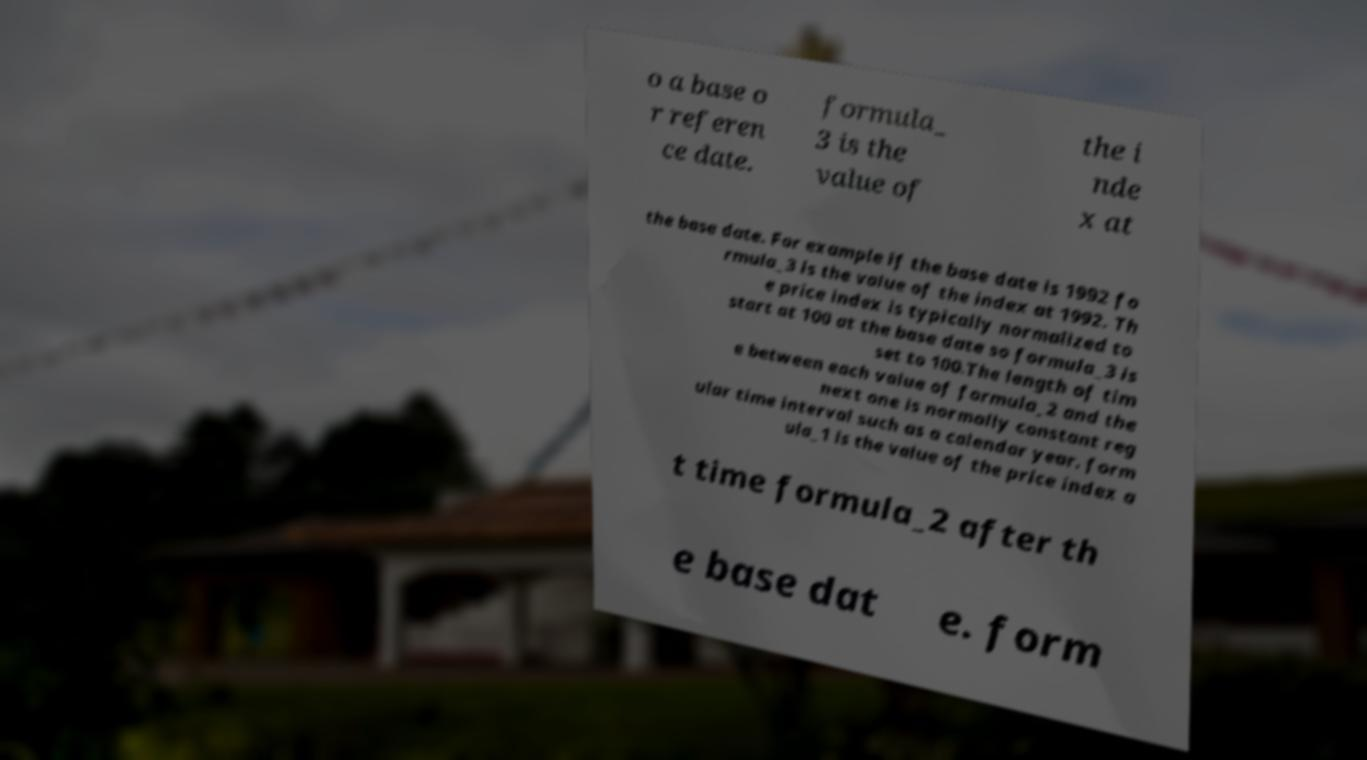Please read and relay the text visible in this image. What does it say? o a base o r referen ce date. formula_ 3 is the value of the i nde x at the base date. For example if the base date is 1992 fo rmula_3 is the value of the index at 1992. Th e price index is typically normalized to start at 100 at the base date so formula_3 is set to 100.The length of tim e between each value of formula_2 and the next one is normally constant reg ular time interval such as a calendar year. form ula_1 is the value of the price index a t time formula_2 after th e base dat e. form 